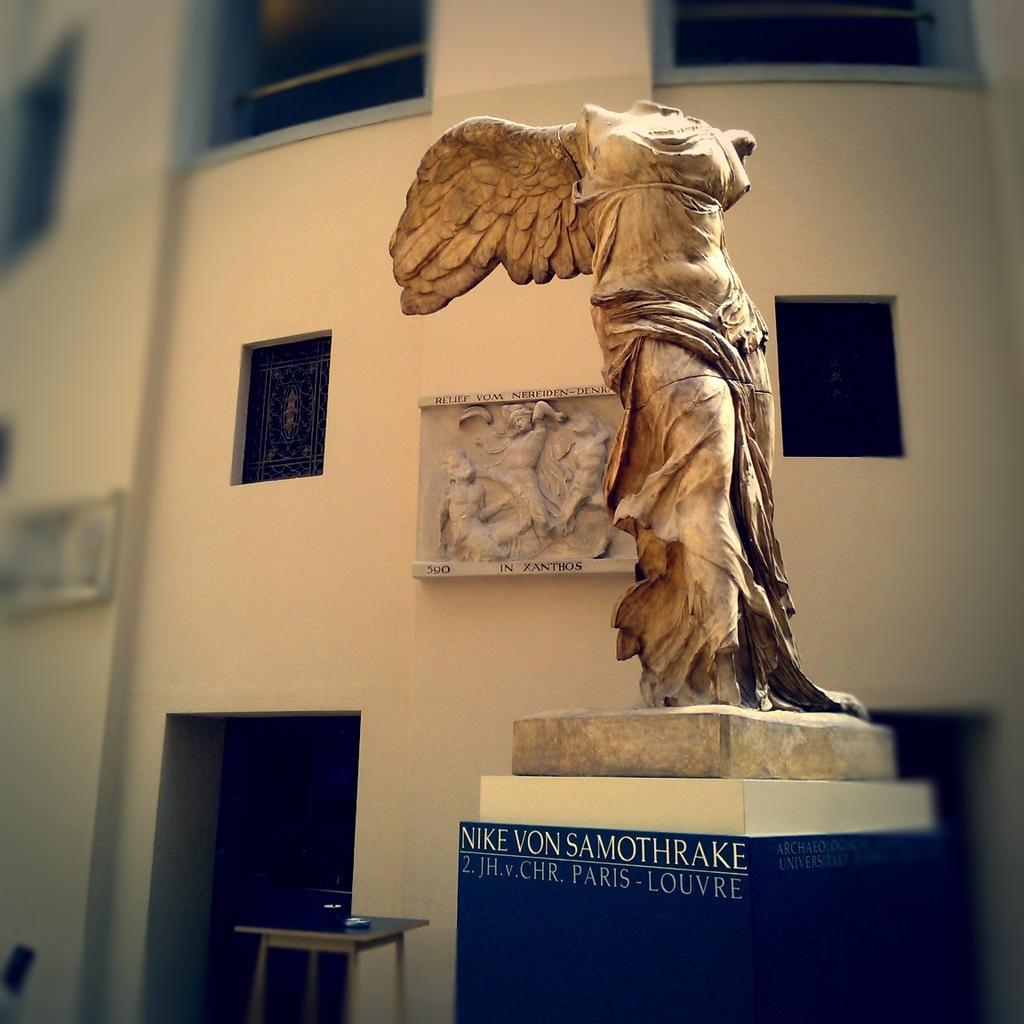Describe this image in one or two sentences. In this image we can see a statue and some text on the blue color wall. In the background, we can see a wall frame on the wall and a table here. This part of the image is slightly blurred. 